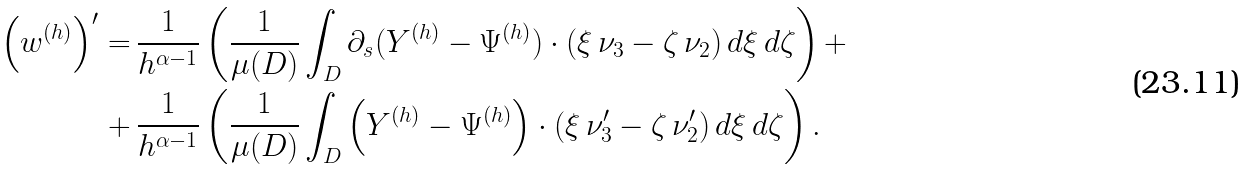<formula> <loc_0><loc_0><loc_500><loc_500>\left ( w ^ { ( h ) } \right ) ^ { \prime } = & \, \frac { 1 } { h ^ { \alpha - 1 } } \left ( \frac { 1 } { \mu ( D ) } \int _ { D } \partial _ { s } ( Y ^ { ( h ) } - \Psi ^ { ( h ) } ) \cdot ( \xi \, \nu _ { 3 } - \zeta \, \nu _ { 2 } ) \, d \xi \, d \zeta \right ) + \\ + & \, \frac { 1 } { h ^ { \alpha - 1 } } \left ( \frac { 1 } { \mu ( D ) } \int _ { D } \left ( Y ^ { ( h ) } - \Psi ^ { ( h ) } \right ) \cdot ( \xi \, \nu ^ { \prime } _ { 3 } - \zeta \, \nu ^ { \prime } _ { 2 } ) \, d \xi \, d \zeta \right ) .</formula> 